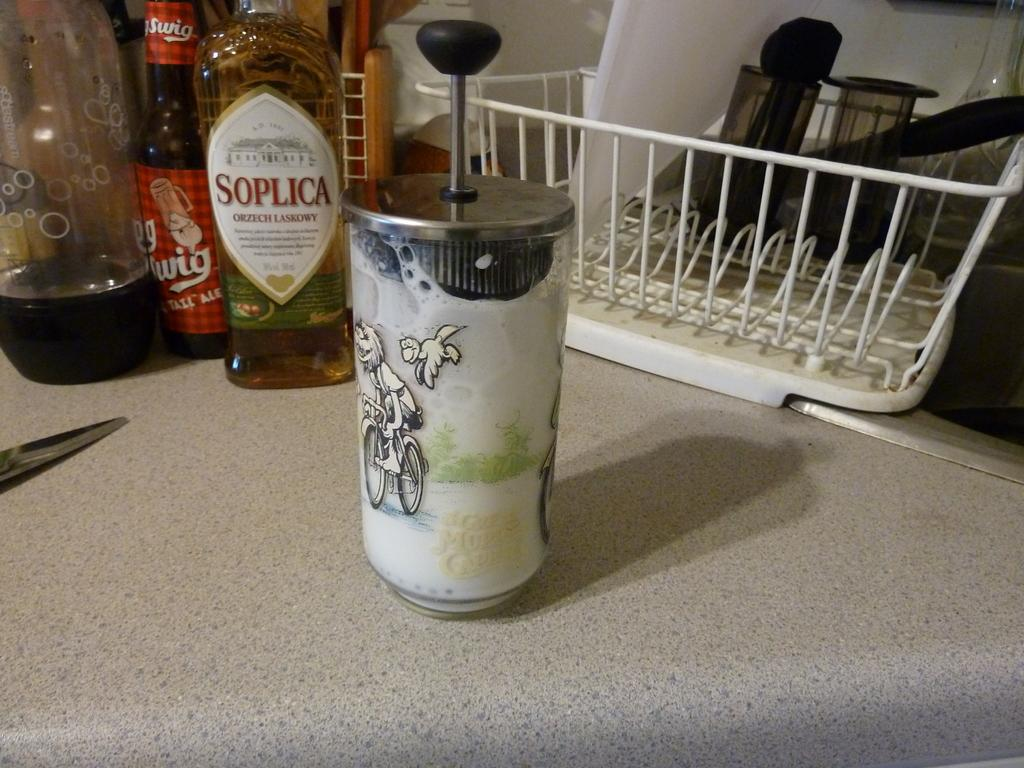<image>
Give a short and clear explanation of the subsequent image. Bottle of Soplica in the kitchen next to a Swig bottle. 